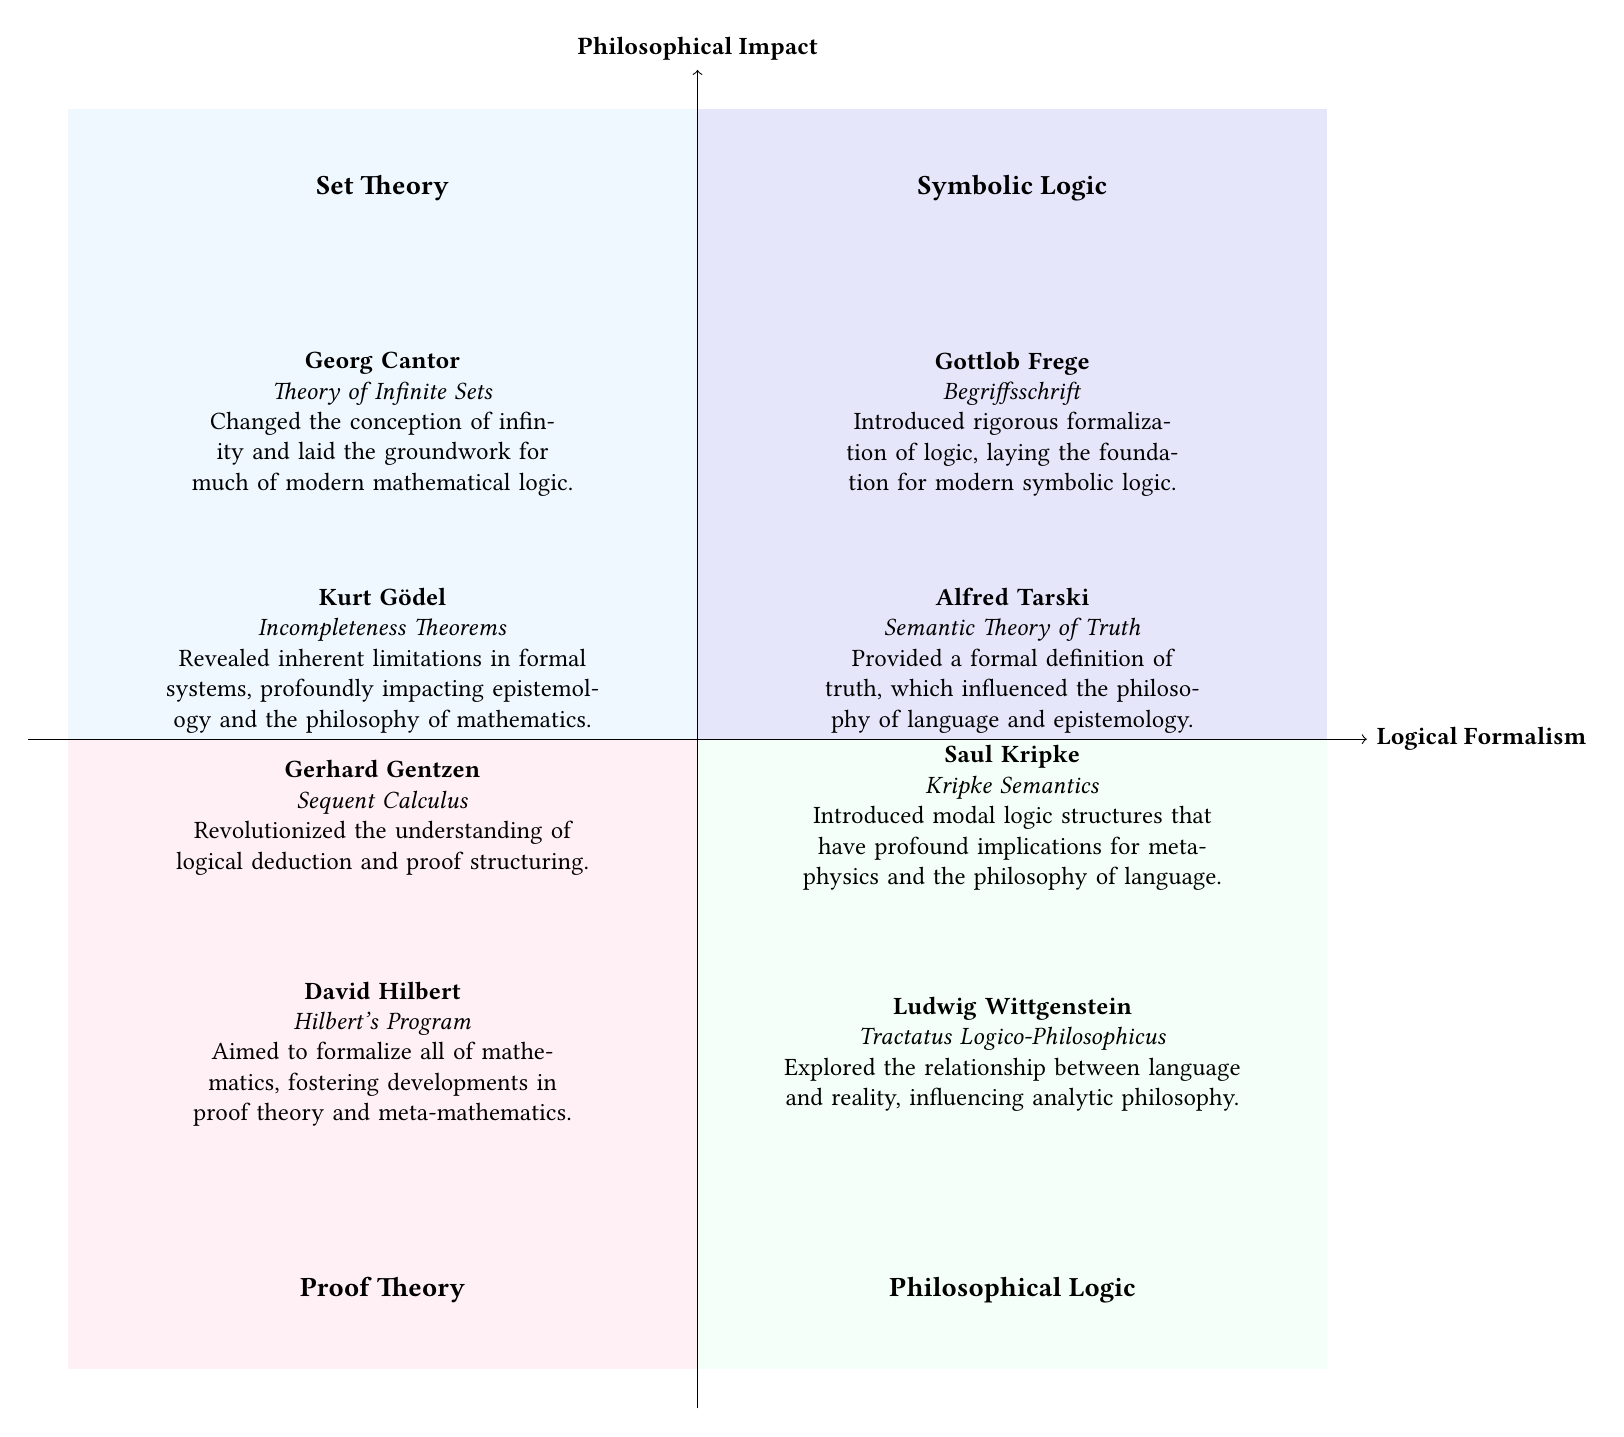What are the two theories represented in the Symbolic Logic quadrant? The Symbolic Logic quadrant contains two thinkers: Gottlob Frege and Alfred Tarski. Their contributions are noted directly within this section of the diagram.
Answer: Gottlob Frege, Alfred Tarski Who contributed the Incompleteness Theorems? The quadrant labeled Set Theory identifies Kurt Gödel as the contributor of the Incompleteness Theorems. This information is explicitly presented in the diagram within that quadrant.
Answer: Kurt Gödel What is the philosophical significance of Saul Kripke’s work? In the Philosophical Logic quadrant, the significance of Saul Kripke's work on Kripke Semantics is highlighted. It discusses its profound implications for metaphysics and the philosophy of language, which combines both critical aspects of his contribution.
Answer: Profound implications for metaphysics and the philosophy of language How many elements are represented in the Proof Theory quadrant? The Proof Theory quadrant includes two elements, which are David Hilbert and Gerhard Gentzen, as observed from the information listed under this section of the diagram.
Answer: Two Which thinker is associated with the Begriffsschrift? The diagram indicates that Gottlob Frege is the thinker associated with Begriffsschrift in the Symbolic Logic quadrant. This specific contribution is stated clearly next to his name.
Answer: Gottlob Frege What does Gerhard Gentzen’s contribution focus on? The contribution of Gerhard Gentzen is centered around Sequent Calculus, noted in the Proof Theory quadrant. This is where the unique focus on logical deduction and proof structuring is discussed.
Answer: Sequent Calculus What quadrant is concerned with the relationship between language and reality? The relationship between language and reality is explored in the Philosophical Logic quadrant, where Ludwig Wittgenstein’s Tractatus Logico-Philosophicus is highlighted. This identifies the thematic focus of that quadrant.
Answer: Philosophical Logic Which quadrant features a thinker who changed the conception of infinity? The Set Theory quadrant features Georg Cantor as the thinker who changed the conception of infinity, as stated directly in the diagram related to his contributions.
Answer: Set Theory How many quadrants are dedicated to Symbolic Logic and Proof Theory combined? The quadrants dedicated to Symbolic Logic and Proof Theory collectively create a total of two quadrants, as each has a distinct section of the diagram representing its content.
Answer: Two 